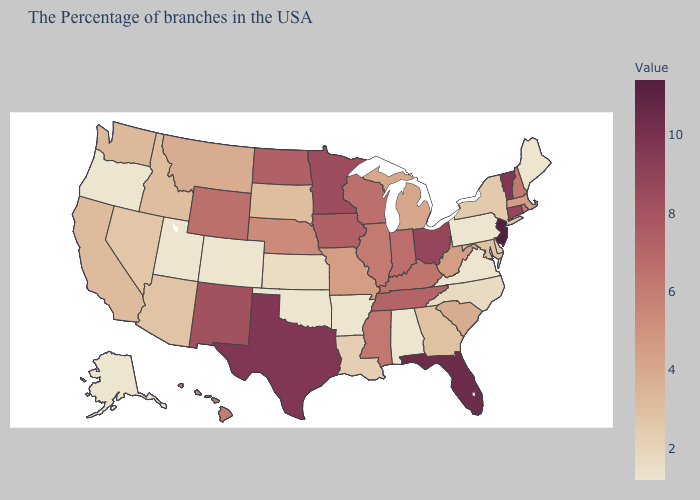Does Louisiana have the highest value in the USA?
Answer briefly. No. Is the legend a continuous bar?
Keep it brief. Yes. Does New Mexico have the highest value in the West?
Concise answer only. Yes. Does Kansas have the lowest value in the MidWest?
Quick response, please. Yes. Does the map have missing data?
Short answer required. No. 